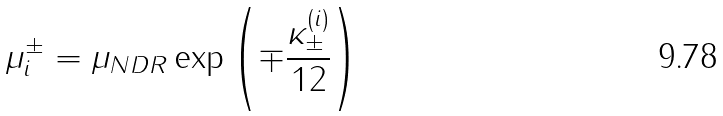<formula> <loc_0><loc_0><loc_500><loc_500>\mu _ { i } ^ { \pm } = \mu _ { N D R } \exp \left ( \mp \frac { \kappa _ { \pm } ^ { ( i ) } } { 1 2 } \right )</formula> 